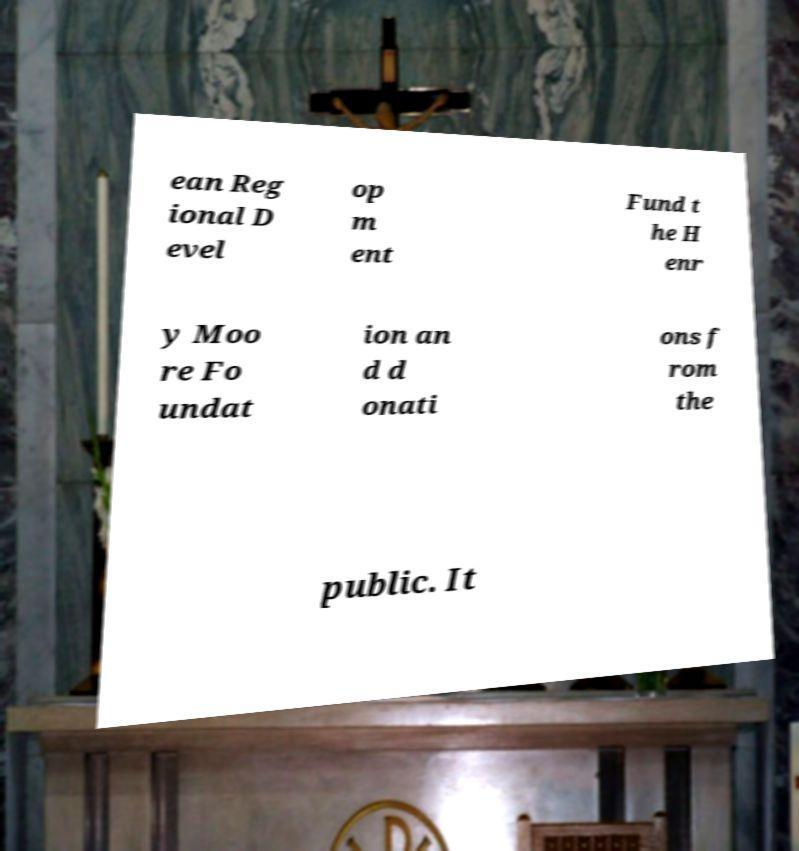I need the written content from this picture converted into text. Can you do that? ean Reg ional D evel op m ent Fund t he H enr y Moo re Fo undat ion an d d onati ons f rom the public. It 